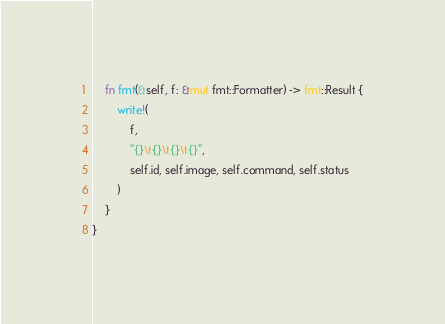<code> <loc_0><loc_0><loc_500><loc_500><_Rust_>    fn fmt(&self, f: &mut fmt::Formatter) -> fmt::Result {
        write!(
            f,
            "{}\t{}\t{}\t{}",
            self.id, self.image, self.command, self.status
        )
    }
}
</code> 